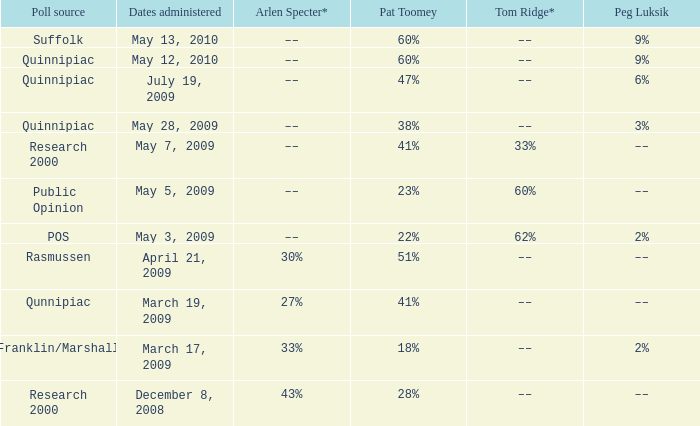Which Tom Ridge* has a Pat Toomey of 60%, and a Poll source of suffolk? ––. 